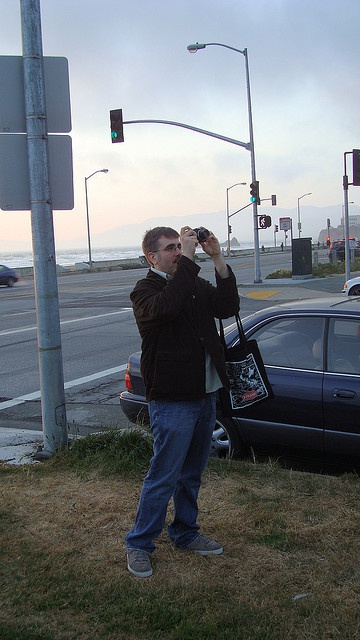Describe the objects in this image and their specific colors. I can see people in lavender, black, navy, and gray tones, car in lavender, black, gray, darkblue, and navy tones, handbag in lavender, black, gray, and blue tones, traffic light in lavender, black, purple, and gray tones, and car in lavender, black, gray, and navy tones in this image. 